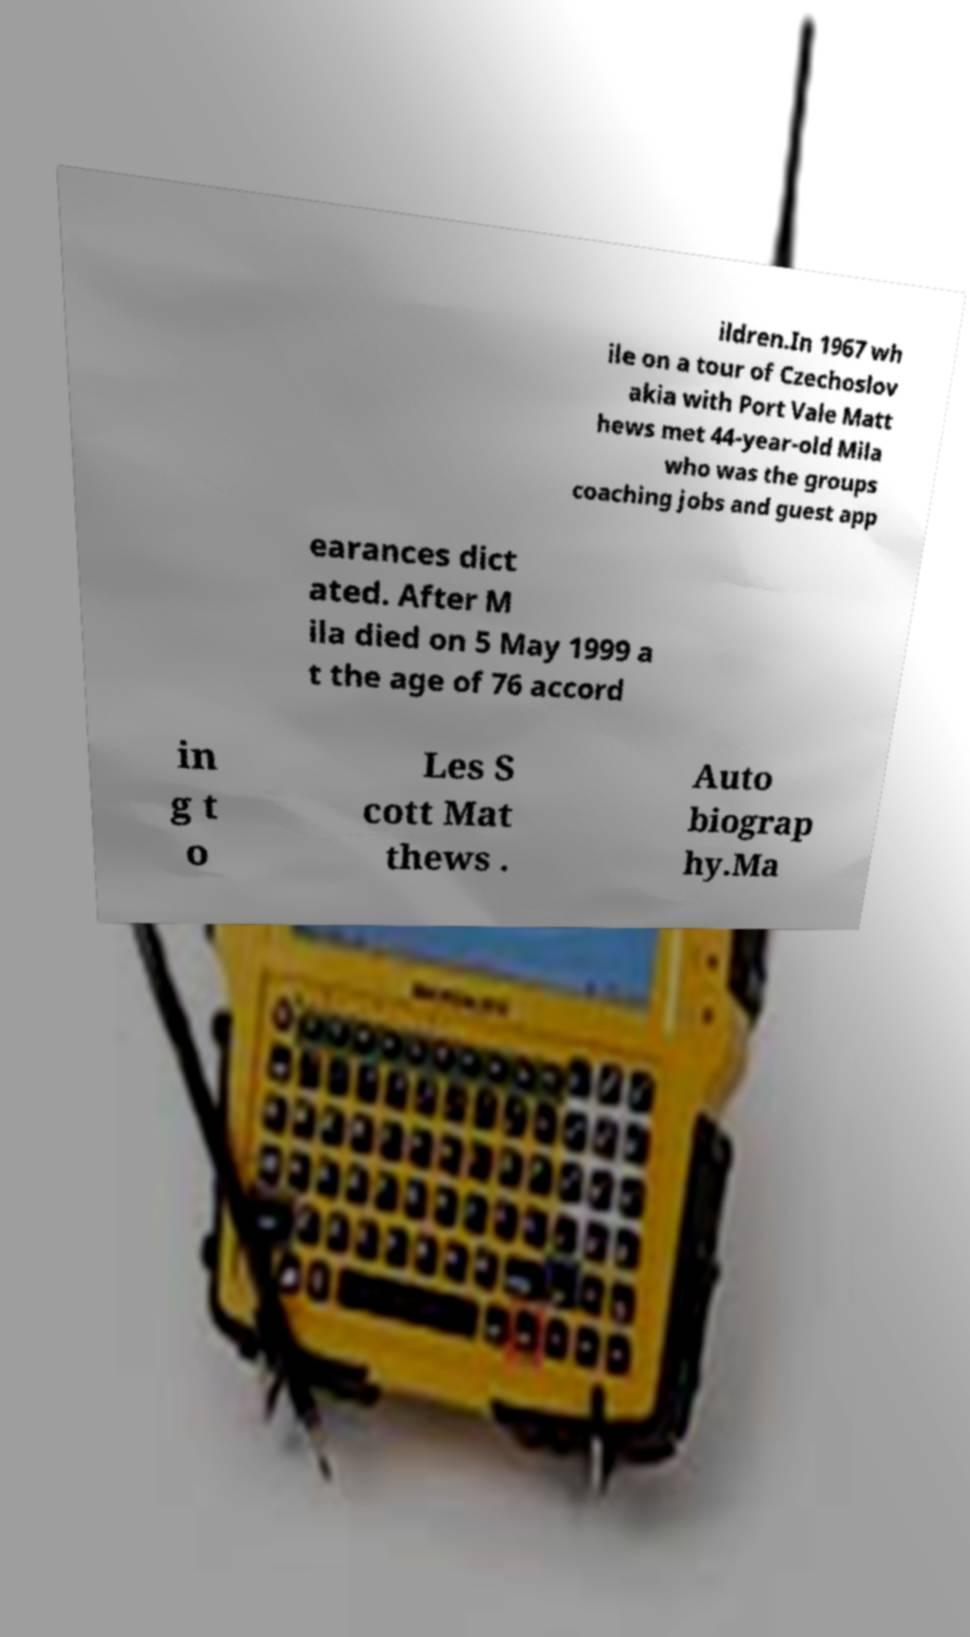Please identify and transcribe the text found in this image. ildren.In 1967 wh ile on a tour of Czechoslov akia with Port Vale Matt hews met 44-year-old Mila who was the groups coaching jobs and guest app earances dict ated. After M ila died on 5 May 1999 a t the age of 76 accord in g t o Les S cott Mat thews . Auto biograp hy.Ma 